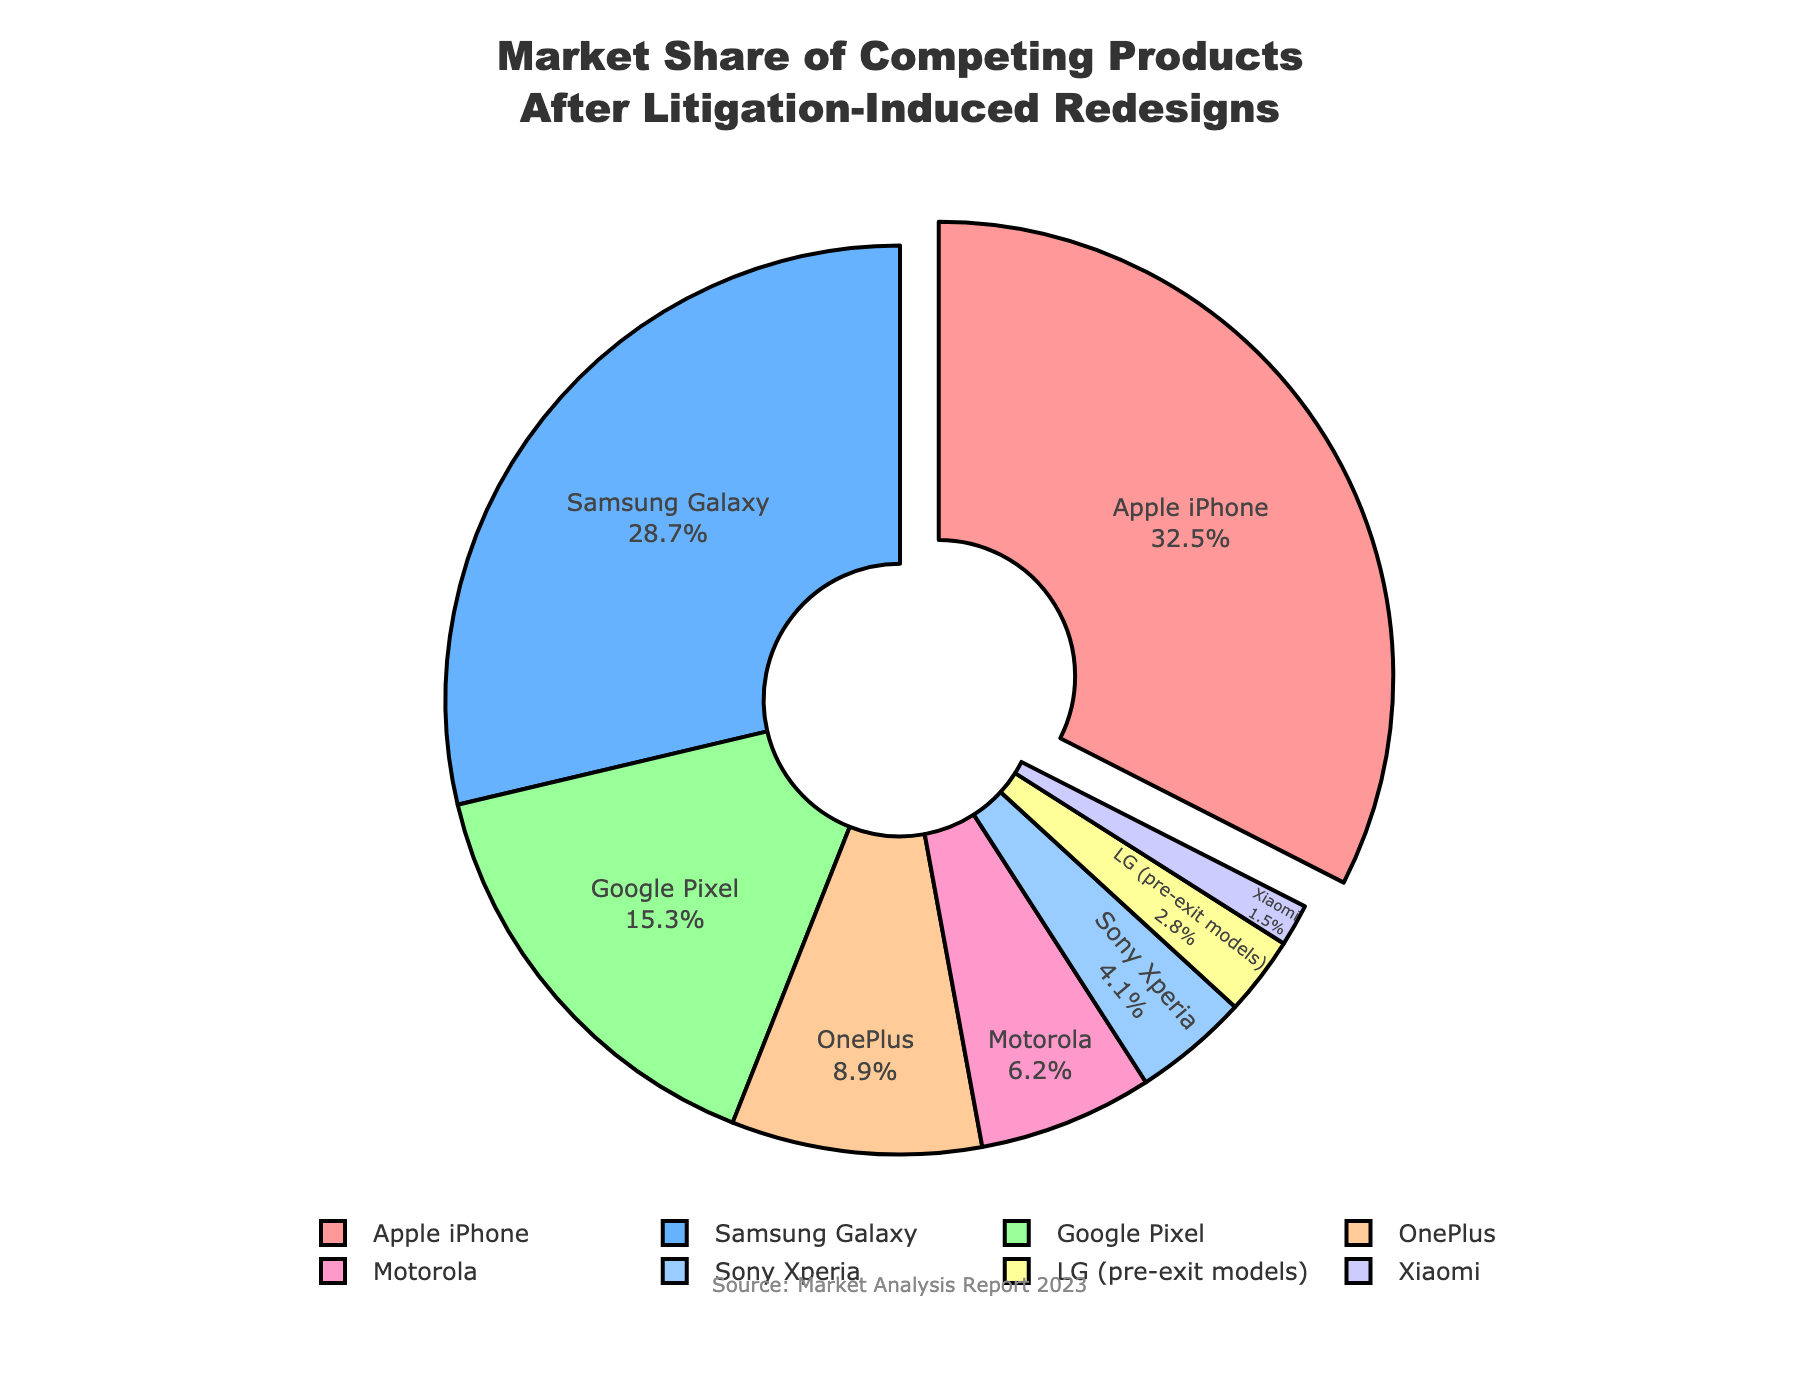What is the market share of the Apple iPhone, and how does it compare to the total market share of the Google Pixel and OnePlus combined? The market share of the Apple iPhone is 32.5%. Adding the market shares of Google Pixel (15.3%) and OnePlus (8.9%), we get 15.3 + 8.9 = 24.2%. Therefore, the Apple iPhone has a higher market share compared to the combined market share of Google Pixel and OnePlus.
Answer: Apple iPhone: 32.5%, Google Pixel + OnePlus: 24.2% Which product has the second-largest market share, and what is its value? The product with the second-largest market share is the Samsung Galaxy, with a market share of 28.7%.
Answer: Samsung Galaxy: 28.7% How does the market share of Motorola compare to that of Sony Xperia? The market share of Motorola is 6.2%, while that of Sony Xperia is 4.1%. Hence, Motorola has a higher market share compared to Sony Xperia.
Answer: Motorola: 6.2%, Sony Xperia: 4.1% What is the combined market share of products with less than 10% market share? The products with less than 10% market share are Google Pixel (15.3%), OnePlus (8.9%), Motorola (6.2%), Sony Xperia (4.1%), LG (2.8%), and Xiaomi (1.5%). Adding these shares, we get 6.2 + 4.1 + 2.8 + 1.5 = 14.6%.
Answer: 14.6% Identify which product is visually pulled out from the pie chart, and state why it might be highlighted this way. The product visually pulled out from the pie chart is the Apple iPhone. It might be highlighted this way to emphasize that it has the largest market share.
Answer: Apple iPhone What is the difference in market share between the lowest (Xiaomi) and highest (Apple iPhone) shares? The market share of the Apple iPhone is 32.5%, while that of Xiaomi is 1.5%. The difference is 32.5 - 1.5 = 31%.
Answer: 31% 